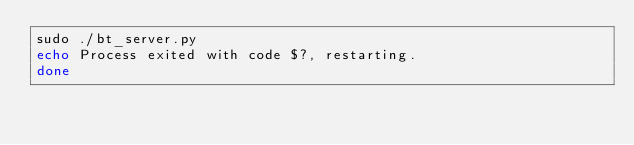Convert code to text. <code><loc_0><loc_0><loc_500><loc_500><_Bash_>sudo ./bt_server.py
echo Process exited with code $?, restarting.
done

</code> 